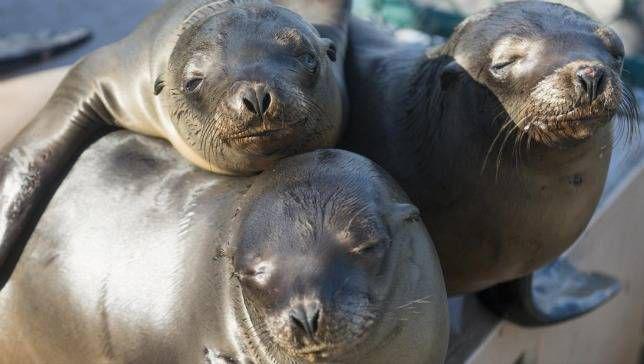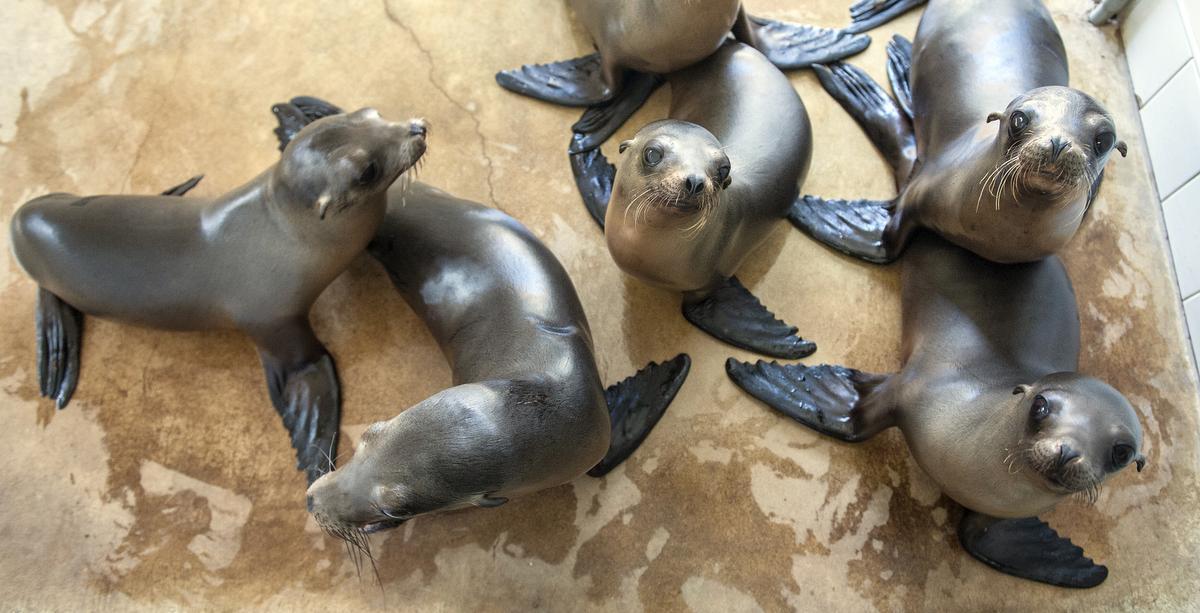The first image is the image on the left, the second image is the image on the right. Considering the images on both sides, is "There are no baby animals in at least one of the images." valid? Answer yes or no. Yes. The first image is the image on the left, the second image is the image on the right. Assess this claim about the two images: "One image shows exactly three seals clustered together, in the foreground.". Correct or not? Answer yes or no. Yes. 